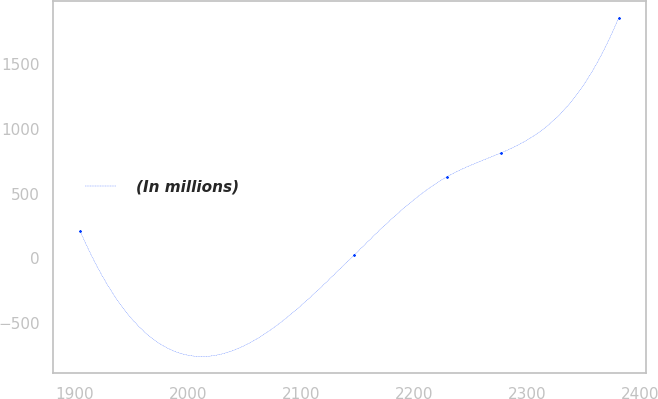<chart> <loc_0><loc_0><loc_500><loc_500><line_chart><ecel><fcel>(In millions)<nl><fcel>1904.94<fcel>209.37<nl><fcel>2147.21<fcel>26.17<nl><fcel>2229.59<fcel>631.88<nl><fcel>2277.2<fcel>815.08<nl><fcel>2381.07<fcel>1858.15<nl></chart> 